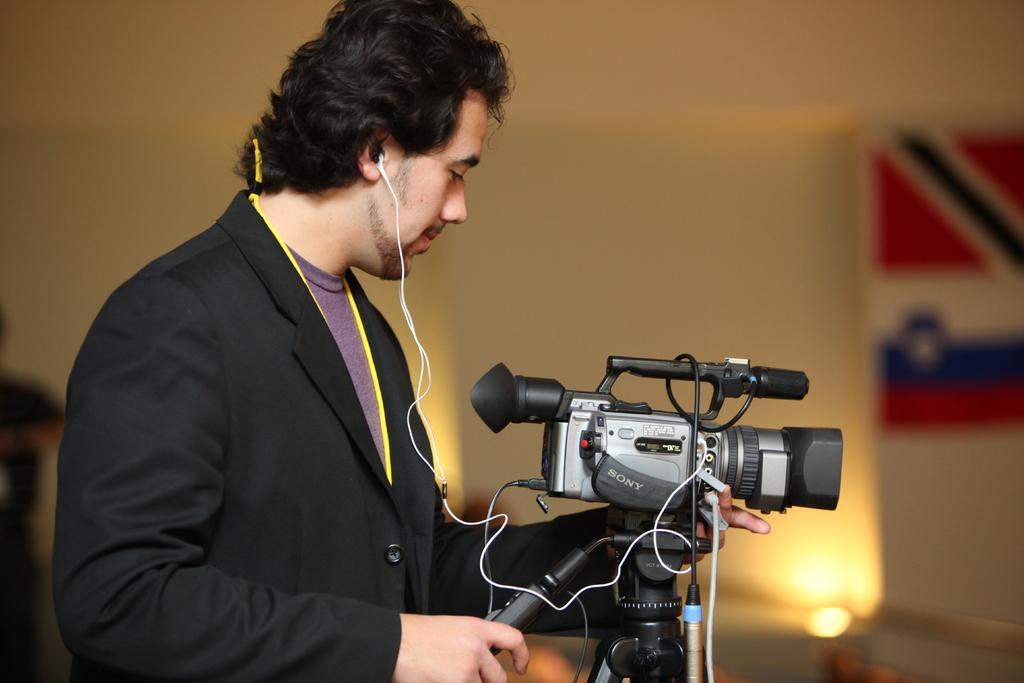What is happening in the center of the image? There are persons standing in the center of the image. What direction are the persons facing? The persons are facing the camera. What can be seen in the background of the image? There is a wall in the background of the image. What type of floor can be seen in the image? There is no information about the floor in the image, as the focus is on the persons standing in the center and the wall in the background. 